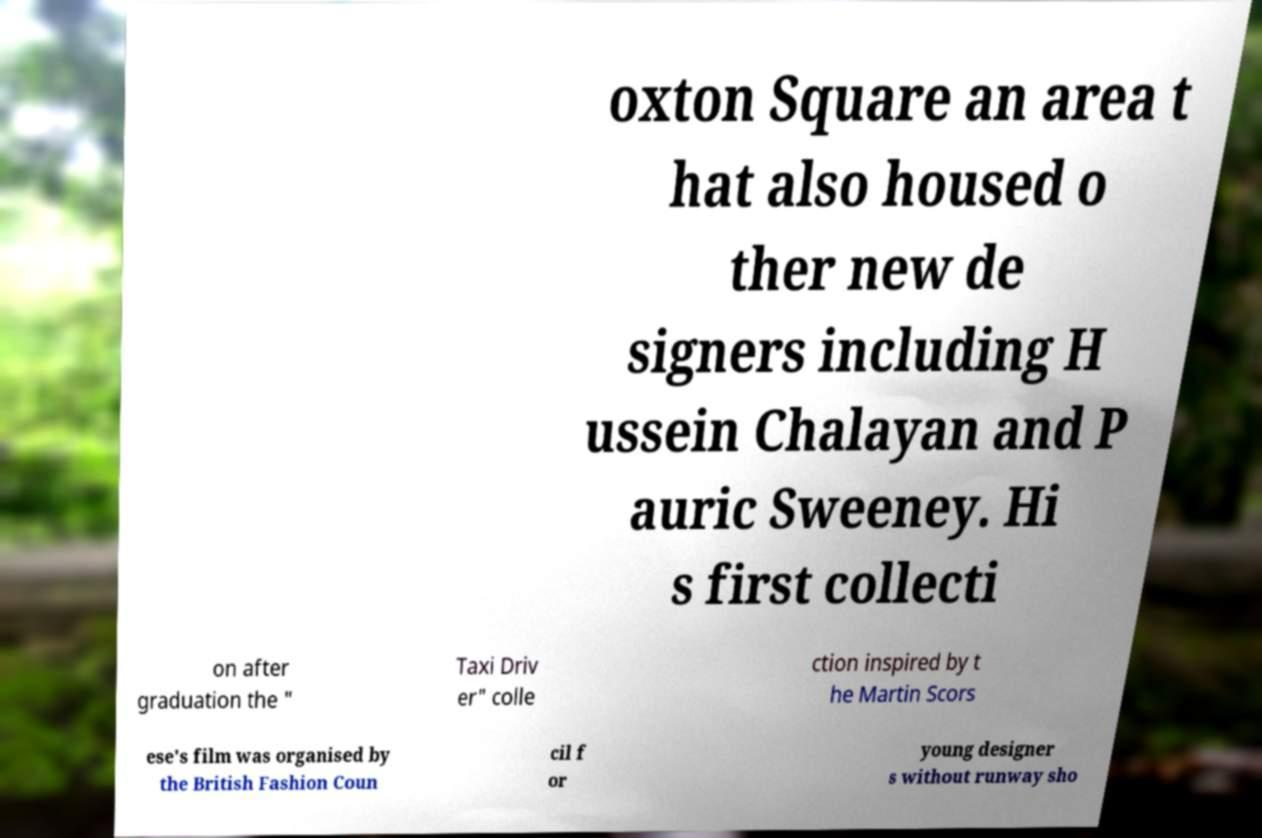There's text embedded in this image that I need extracted. Can you transcribe it verbatim? oxton Square an area t hat also housed o ther new de signers including H ussein Chalayan and P auric Sweeney. Hi s first collecti on after graduation the " Taxi Driv er" colle ction inspired by t he Martin Scors ese's film was organised by the British Fashion Coun cil f or young designer s without runway sho 